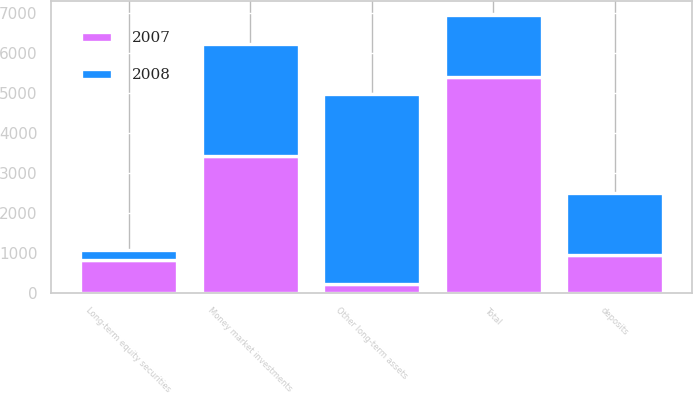<chart> <loc_0><loc_0><loc_500><loc_500><stacked_bar_chart><ecel><fcel>Money market investments<fcel>Long-term equity securities<fcel>deposits<fcel>Other long-term assets<fcel>Total<nl><fcel>2007<fcel>3426<fcel>812<fcel>957<fcel>210<fcel>5405<nl><fcel>2008<fcel>2795<fcel>270<fcel>1549<fcel>4772<fcel>1549<nl></chart> 